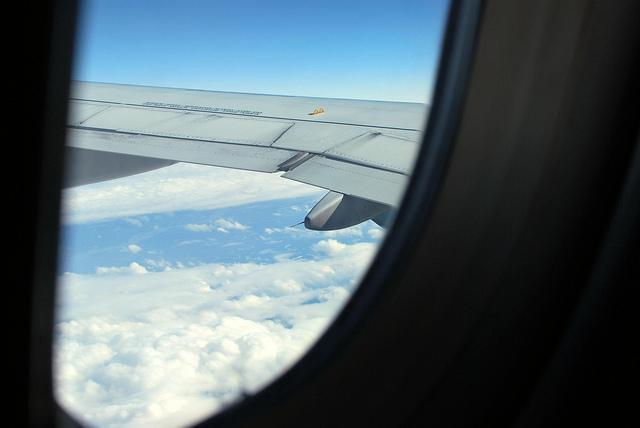How many of the people are holding yellow tape?
Give a very brief answer. 0. 